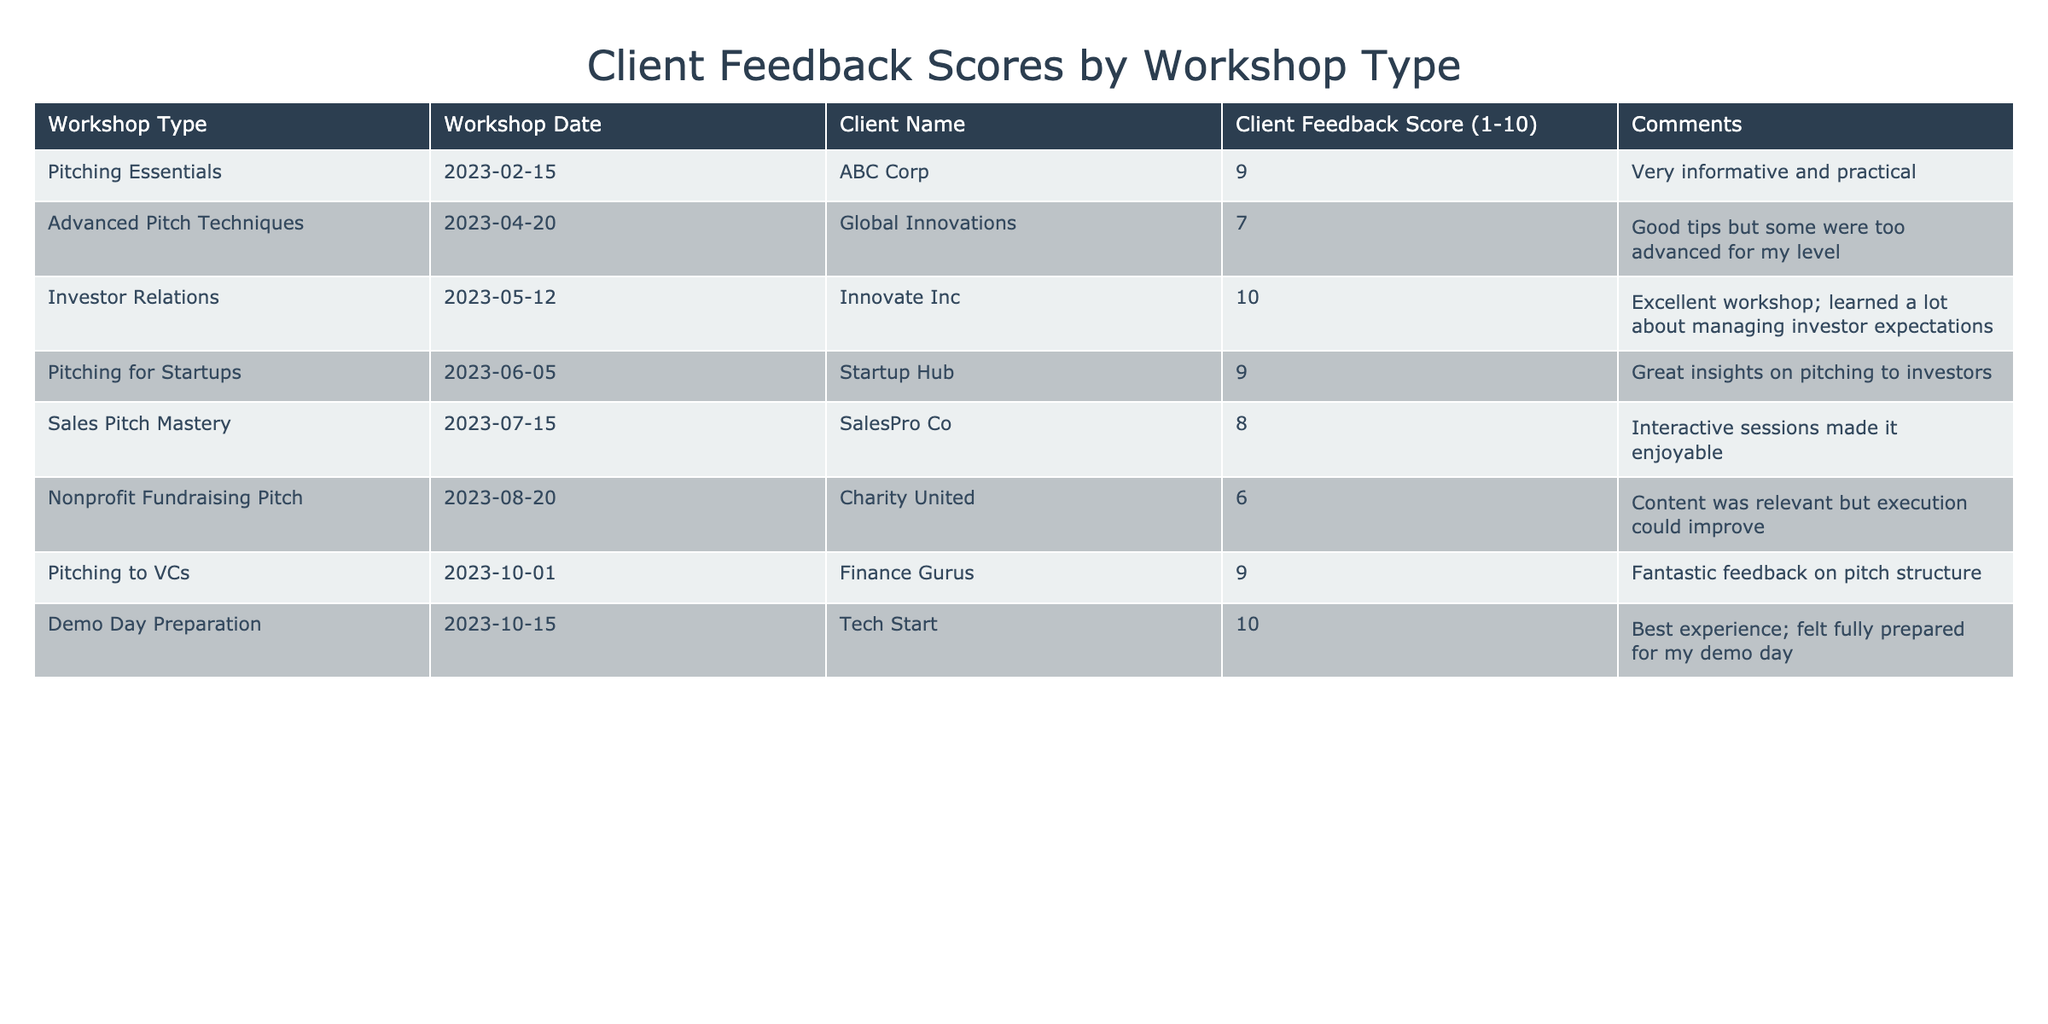What is the highest client feedback score among the workshops? The highest client feedback score in the table is 10, which can be found in the feedback score for the "Investor Relations" and "Demo Day Preparation" workshops.
Answer: 10 What is the average client feedback score across all workshop types? To find the average, sum the scores: (9 + 7 + 10 + 9 + 8 + 6 + 9 + 10) = 78. There are 8 workshops, so the average is 78 / 8 = 9.75.
Answer: 9.75 Which workshop received the lowest client feedback score? The lowest score in the table is 6, which corresponds to the "Nonprofit Fundraising Pitch" workshop.
Answer: Nonprofit Fundraising Pitch Did "Sales Pitch Mastery" receive a higher score than "Advanced Pitch Techniques"? Yes, "Sales Pitch Mastery" received a score of 8, while "Advanced Pitch Techniques" received a score of 7.
Answer: Yes What percentage of workshops received a score of 8 or higher? There are 5 workshops with scores of 8 or higher (9, 10, 9, 9, and 10) out of a total of 8 workshops. To find the percentage: (5/8) * 100 = 62.5%.
Answer: 62.5% How many workshops had comments that mentioned the content was informative? The workshops that had comments mentioning informative content are "Pitching Essentials," "Investor Relations," "Pitching for Startups," and "Demo Day Preparation," totaling 4 workshops.
Answer: 4 What is the difference between the highest score and the lowest score? The highest score is 10 and the lowest score is 6. The difference is 10 - 6 = 4.
Answer: 4 Which workshop had both the highest score and the highest comment quality based on the feedback? The "Demo Day Preparation" workshop had a score of 10 and the comment stated it was the "Best experience," which indicates very high quality.
Answer: Demo Day Preparation How many workshops were held in 2023, and what was the average score for those workshops? All workshops listed are from 2023, totaling 8. The total score is 78, so the average is 78 / 8 = 9.75.
Answer: 8 workshops, 9.75 average score Is there a workshop that received a score of 10 and had only positive comments? Yes, both "Investor Relations" and "Demo Day Preparation" received scores of 10 and had positive comments indicating high satisfaction.
Answer: Yes 